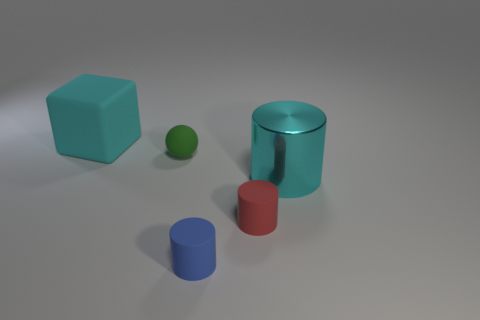Does the large cube have the same color as the large metal cylinder?
Offer a very short reply. Yes. Is there anything else that has the same material as the cyan cylinder?
Your answer should be compact. No. How many cylinders are either red matte objects or cyan matte things?
Provide a succinct answer. 1. What number of large cyan objects are in front of the cyan thing that is behind the big cyan object that is in front of the large cyan block?
Offer a very short reply. 1. Are there any red things made of the same material as the block?
Provide a short and direct response. Yes. Is the material of the cyan block the same as the red object?
Your answer should be very brief. Yes. There is a big cyan object to the left of the cyan metal cylinder; what number of blue rubber objects are in front of it?
Offer a very short reply. 1. How many blue things are large cylinders or tiny balls?
Ensure brevity in your answer.  0. There is a big object in front of the large cyan object that is behind the big thing that is right of the big cyan matte block; what shape is it?
Offer a very short reply. Cylinder. There is another rubber cylinder that is the same size as the blue matte cylinder; what color is it?
Your answer should be very brief. Red. 